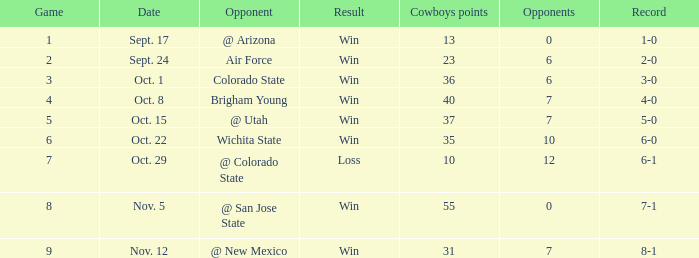What was the cowboys' score for nov. 5, 1966? 7-1. 